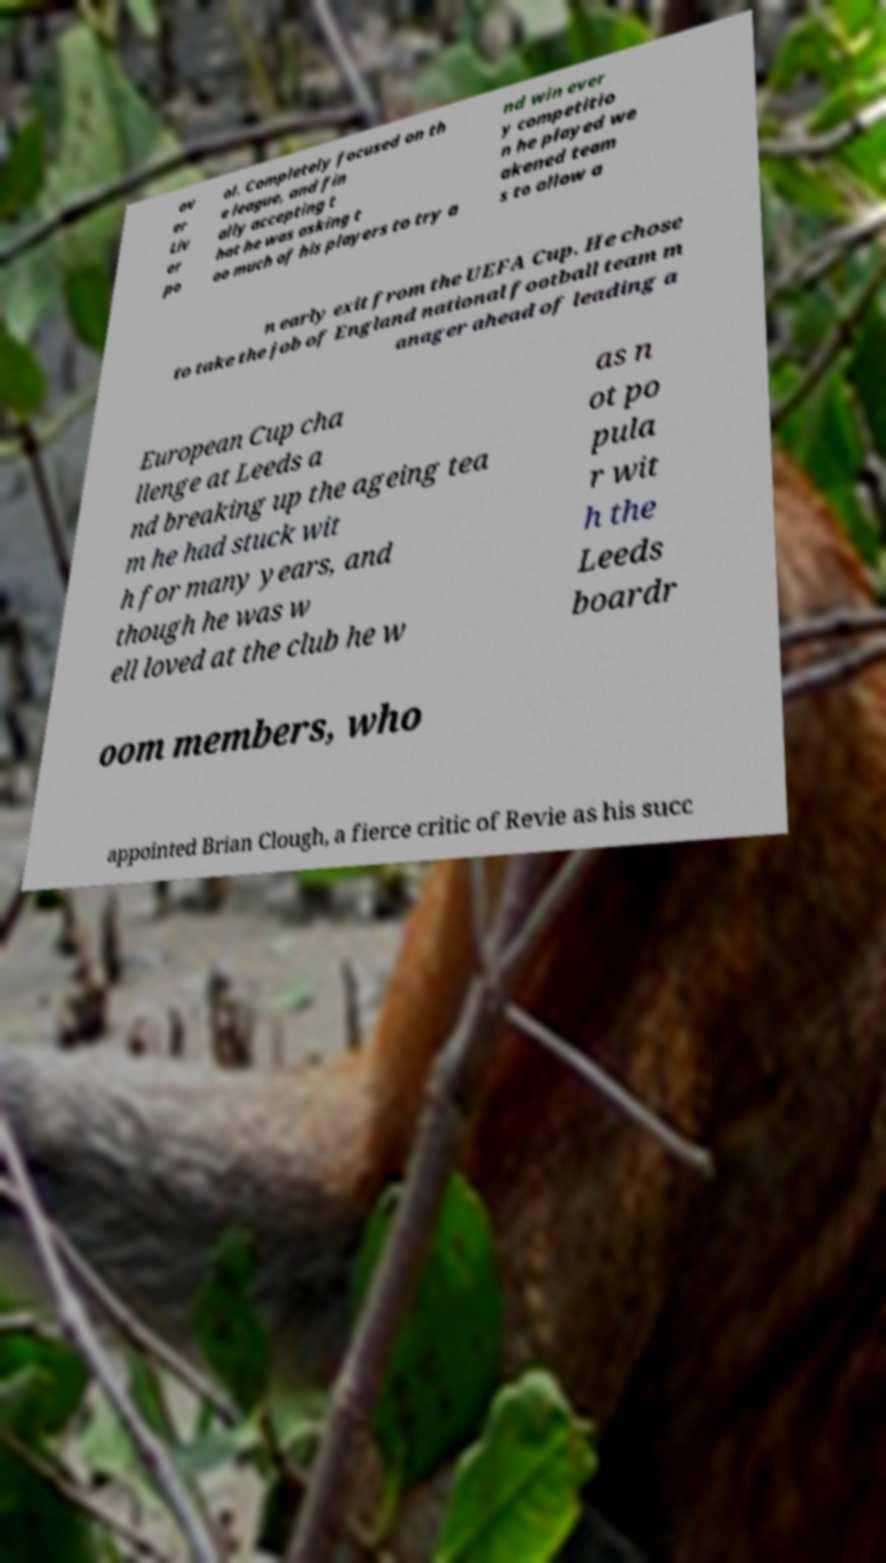What messages or text are displayed in this image? I need them in a readable, typed format. ov er Liv er po ol. Completely focused on th e league, and fin ally accepting t hat he was asking t oo much of his players to try a nd win ever y competitio n he played we akened team s to allow a n early exit from the UEFA Cup. He chose to take the job of England national football team m anager ahead of leading a European Cup cha llenge at Leeds a nd breaking up the ageing tea m he had stuck wit h for many years, and though he was w ell loved at the club he w as n ot po pula r wit h the Leeds boardr oom members, who appointed Brian Clough, a fierce critic of Revie as his succ 